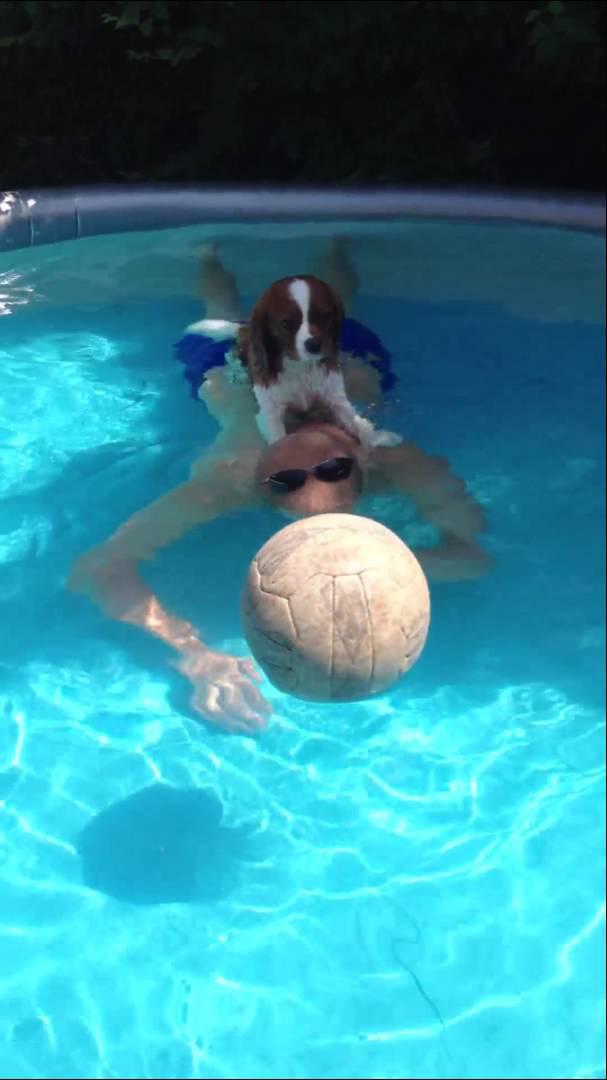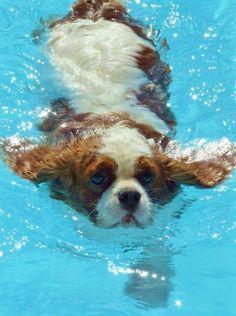The first image is the image on the left, the second image is the image on the right. Examine the images to the left and right. Is the description "There is a brown and white cocker spaniel swimming in a pool" accurate? Answer yes or no. Yes. The first image is the image on the left, the second image is the image on the right. Considering the images on both sides, is "Left image shows a dog swimming leftward." valid? Answer yes or no. No. 